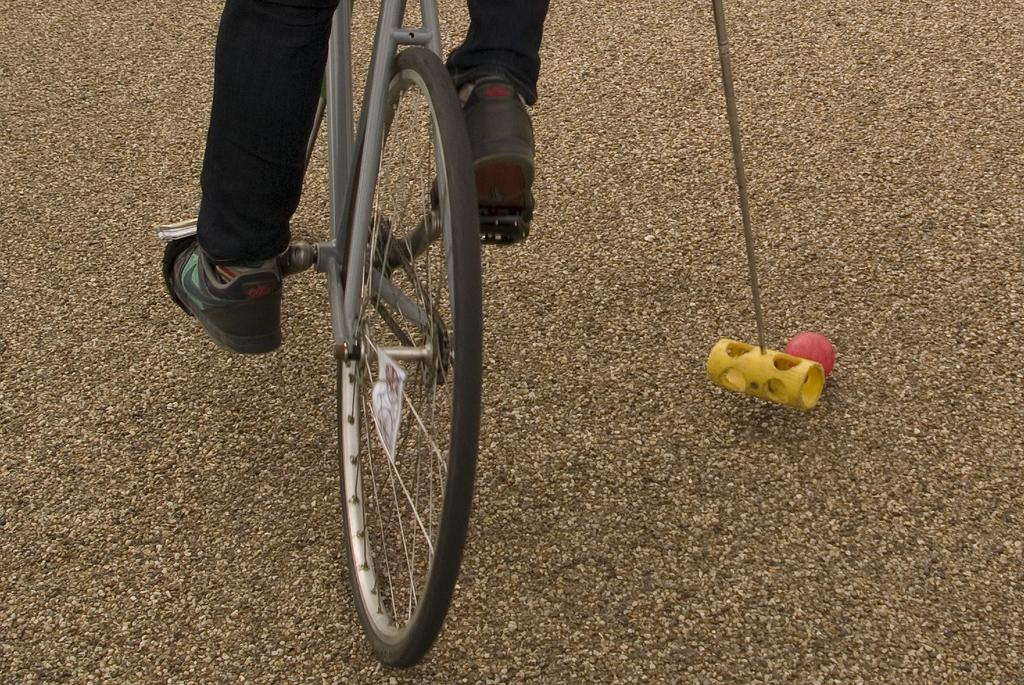What is the main subject of the image? There is a person in the image. What is the person wearing? The person is wearing black pants. What is the person holding in the image? The person is holding a stick. What activity is the person engaged in? The person is cycling on the ground. What object can be seen on the ground in the image? There is a red ball on the ground. How many snakes are slithering around the person in the image? There are no snakes present in the image. What type of food is the person eating while cycling? The image does not show the person eating any food. 